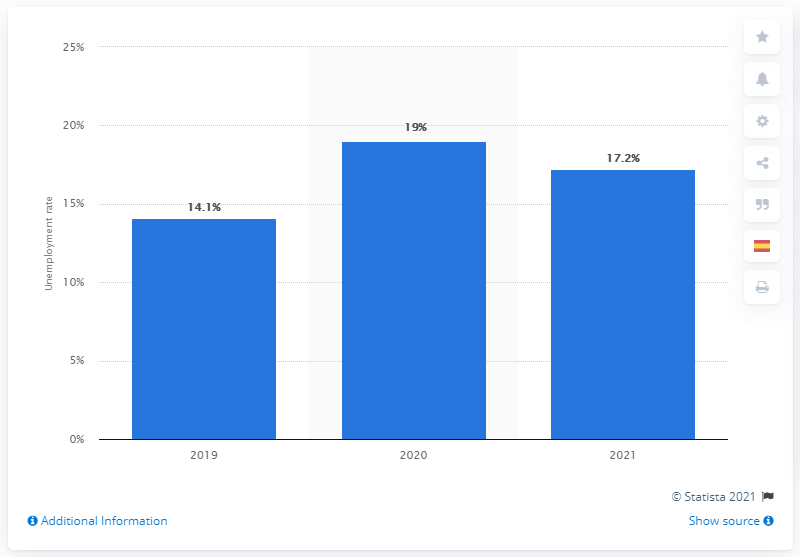Identify some key points in this picture. In 2020, the unemployed population in Spain accounted for [X%] of the total population. 